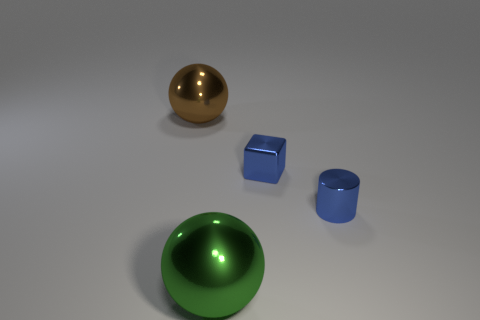How many tiny cyan cubes are there?
Your answer should be very brief. 0. Is there a purple metal sphere that has the same size as the brown thing?
Provide a short and direct response. No. Is the material of the tiny blue cube the same as the green sphere to the left of the blue shiny cylinder?
Provide a succinct answer. Yes. There is a big thing left of the large green metallic sphere; what material is it?
Provide a short and direct response. Metal. What is the size of the blue cylinder?
Offer a very short reply. Small. There is a green shiny object in front of the small blue block; is its size the same as the blue thing that is behind the blue metallic cylinder?
Ensure brevity in your answer.  No. There is another metallic thing that is the same shape as the green shiny object; what size is it?
Keep it short and to the point. Large. Do the block and the shiny sphere on the left side of the green shiny ball have the same size?
Your answer should be compact. No. There is a shiny object on the left side of the big green metal sphere; is there a large shiny sphere that is behind it?
Your response must be concise. No. What is the shape of the large thing behind the blue cylinder?
Offer a very short reply. Sphere. 